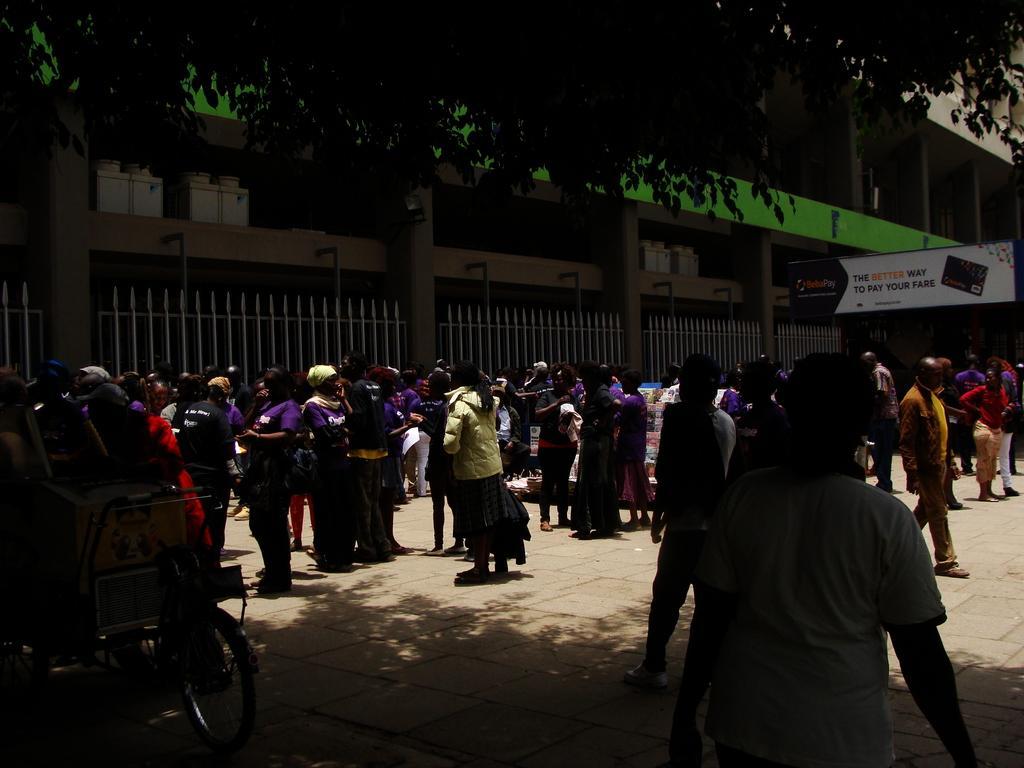Please provide a concise description of this image. In the foreground of this image, there are persons walking and standing on the pavement. On the left, there is a bicycle. On the top, there is the tree. In the background, there is a building and a board. 